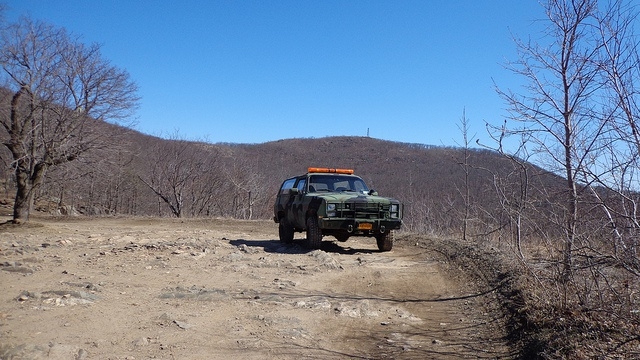Describe the objects in this image and their specific colors. I can see a truck in gray, black, darkgray, and navy tones in this image. 